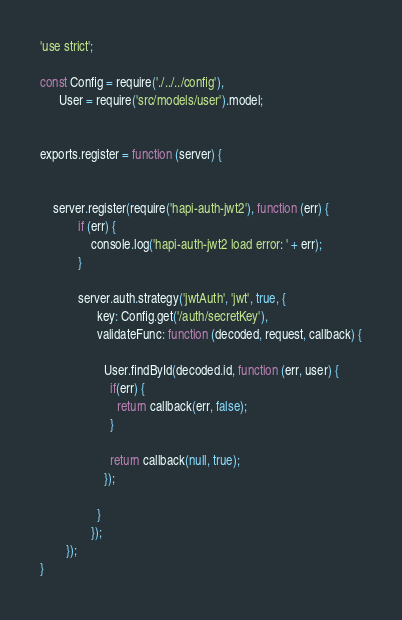Convert code to text. <code><loc_0><loc_0><loc_500><loc_500><_JavaScript_>'use strict';

const Config = require('./../../config'),
      User = require('src/models/user').model;


exports.register = function (server) {


    server.register(require('hapi-auth-jwt2'), function (err) {
            if (err) {
                console.log('hapi-auth-jwt2 load error: ' + err);
            }

            server.auth.strategy('jwtAuth', 'jwt', true, {
                  key: Config.get('/auth/secretKey'),
                  validateFunc: function (decoded, request, callback) {

                    User.findById(decoded.id, function (err, user) {
                      if(err) {
                        return callback(err, false);
                      }

                      return callback(null, true);
                    });

                  }
                });
        });
}
</code> 